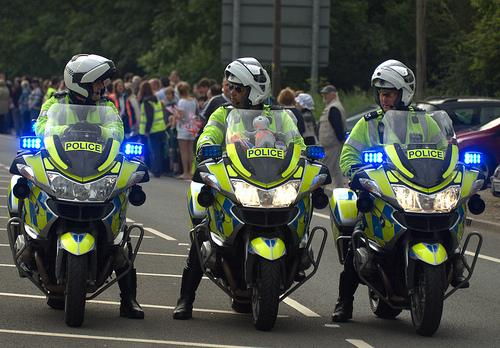Give details of the blue letters on the windshield and their respective positions. Blue letters on the windshield can be found at positions (65, 141), (71, 141), (76, 140), and (81, 140) with widths 7, 9, 10, and 10, and heights 7, 9, 10, and 10 respectively. What is the prominent color of the motorcycles in the image, and how many are there? There are three police motorcycles, which are primarily yellow and blue in color. What kind of lights are present in the image and where are they primarily located? Blue lights on the motorcycles are at position (8, 53) with width 146 and height 146, and other lights not on the motorcycles are at position (191, 68) with width 110 and height 110. Mention the color and location of the writings seen on the windshield. There are blue writings on the windshield at various positions with coordinates such as (77, 142), (86, 140), (93, 142) and so on. Write a few lines describing the scene behind the police officer. There's a roadway behind the police officer at position (148, 195) with width 37 and height 37, and a crowd in the back at position (123, 72) with width 77 and height 77. Describe the unique features of the police officer in the foreground of the image. The police officer in the foreground is wearing a helmet, with a bounding box at position (165, 59) with width 162 and height 162. How many police officers are visible in the image, and do they share any common image parameters? There are three police officers in the image, sharing the common image parameters of width 495 and height 495. How many people are visible in the distance, and do they have any common image parameters? Several people are visible in the distance, sharing common image parameters with widths ranging from 14 to 48 and heights ranging from 14 to 48. Identify the type of sign that stands out in the image and provide its position and size. There is a yellow police sign with blue letters at position (64, 139) with a width of 40 and height of 40. Describe the wall on the side of a building as seen in the image. The wall on the side of a building appears in two locations, one at position (286, 0) with width 39 and height 39, and another at position (9, 90) with width 179 and height 179. 